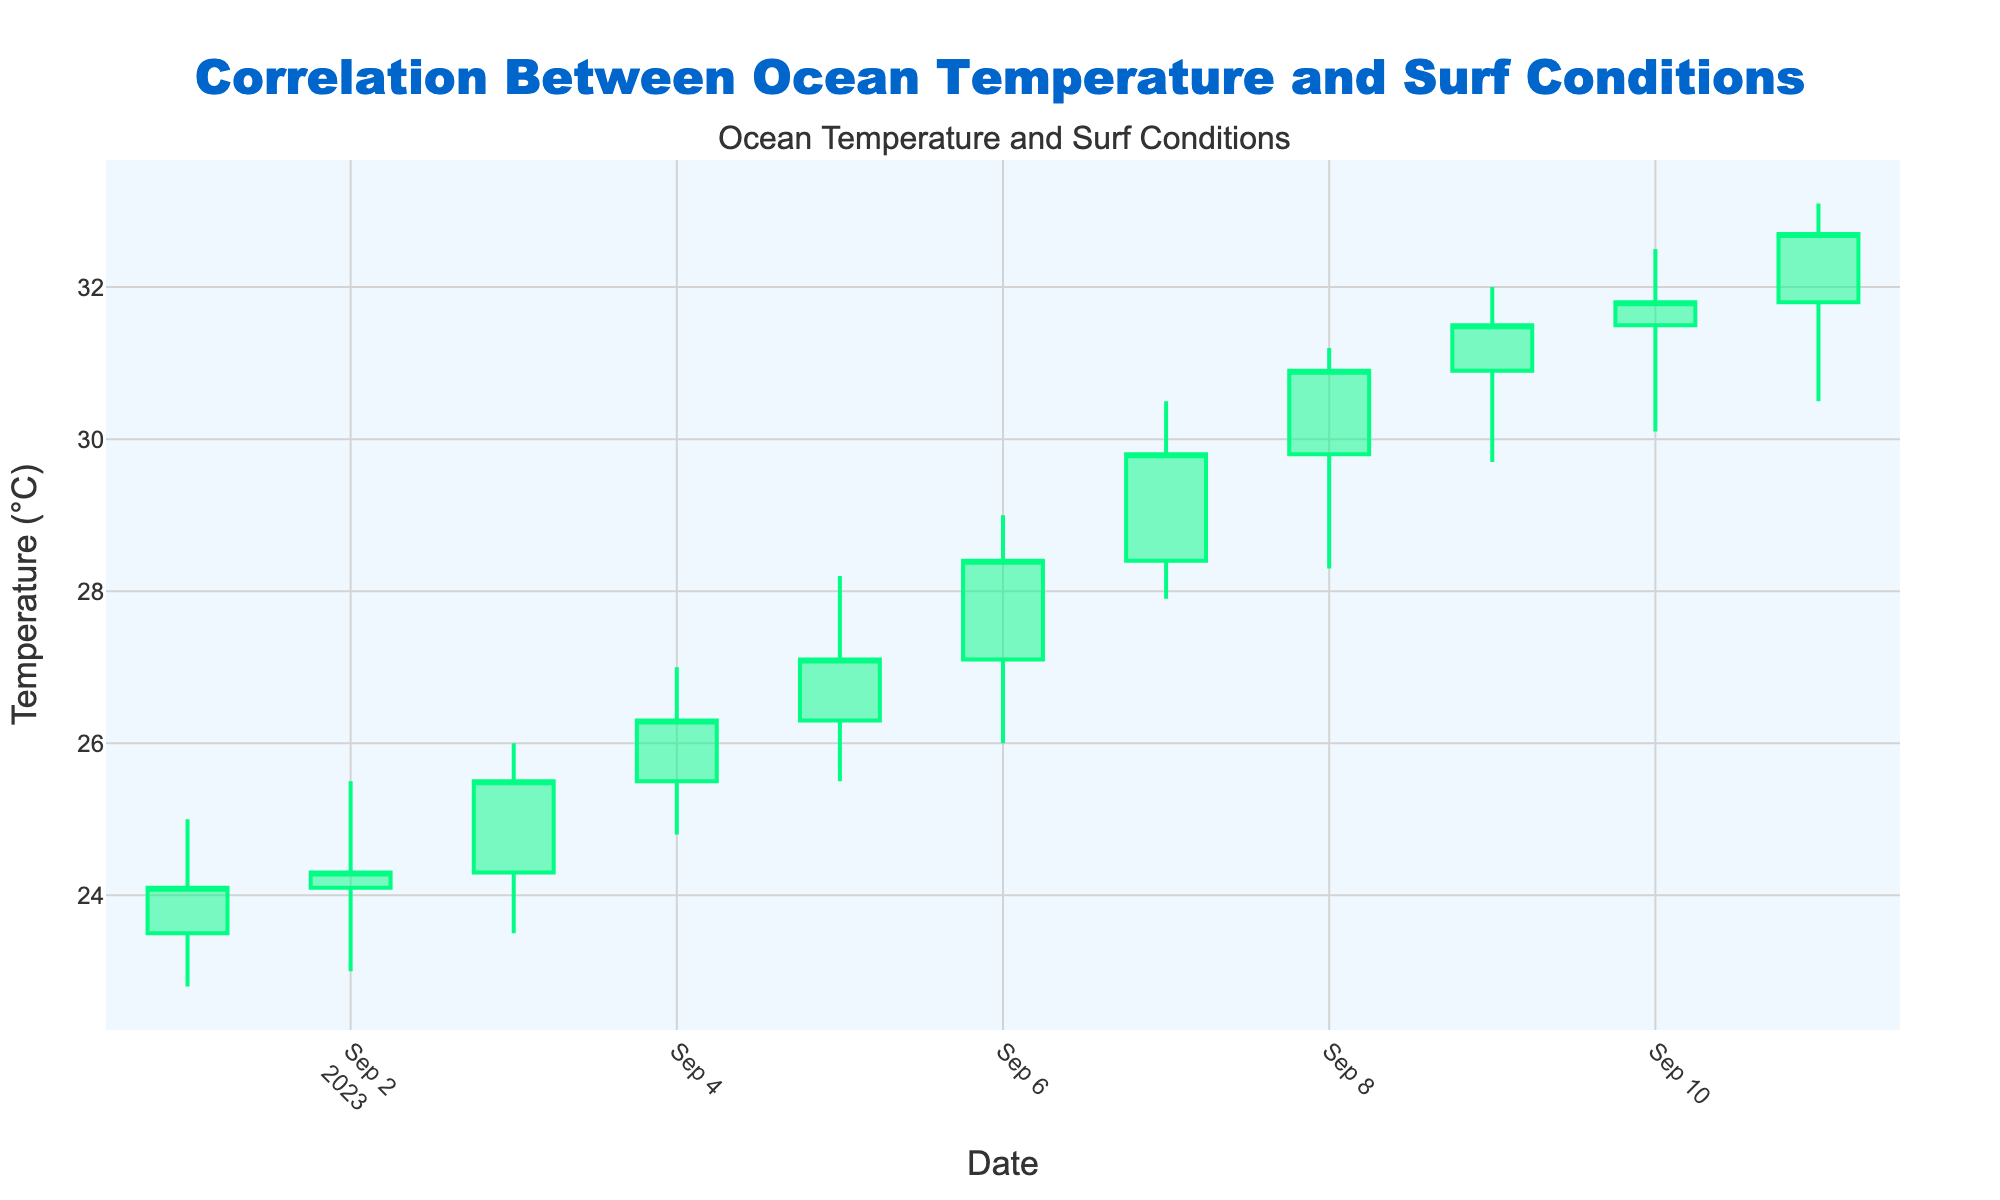What is the title of the figure? The title of the figure can be found at the top center section of the chart. It reads "Correlation Between Ocean Temperature and Surf Conditions".
Answer: Correlation Between Ocean Temperature and Surf Conditions Which date shows the highest ocean temperature based on the candlestick chart? By examining the "High" values on the candlestick chart, the date with the highest ocean temperature is when the High value reaches its peak. The highest temperature is on 2023-09-11, where the High value is 33.1°C.
Answer: 2023-09-11 On which dates did the Close temperature exceed 30°C? Review all the "Close" values displayed on the candlestick chart and identify which ones are above 30°C. The dates where the Close temperature exceeded 30°C are 2023-09-08, 2023-09-09, 2023-09-10, and 2023-09-11.
Answer: 2023-09-08, 2023-09-09, 2023-09-10, 2023-09-11 How does the opening temperature change from the first day to the last day in the provided dataset? Compare the "Open" temperature on the first day (2023-09-01) which is 23.5°C, to the "Open" temperature on the last day (2023-09-11) which is 31.8°C. The opening temperature increased from 23.5°C to 31.8°C.
Answer: Increased from 23.5°C to 31.8°C What is the range of temperatures on 2023-09-05? The range is calculated by subtracting the Low value from the High value for 2023-09-05. The High is 28.2°C and Low is 25.5°C, so the range is 28.2°C - 25.5°C = 2.7°C.
Answer: 2.7°C Which day showed the largest single-day increase in closing temperature? To determine the largest single-day increase, calculate the difference between the previous day's Close and the current day's Close for each day. Comparing all the differences, the largest increase is between 2023-09-06 and 2023-09-07, where the Close increased from 28.4°C to 29.8°C, an increase of 1.4°C.
Answer: 2023-09-07 On what date did the closing temperature decrease compared to the previous day? Compare the closing temperature of consecutive days and identify where the Close value is lower than the previous day. This occurs between 2023-09-10 and 2023-09-11, where the Close fell from 31.8°C to 32.7°C.
Answer: 2023-09-10 What is the average closing temperature over the entire period? Sum all the closing values and then divide by the number of days. The closing temperatures are: 24.1, 24.3, 25.5, 26.3, 27.1, 28.4, 29.8, 30.9, 31.5, 31.8, 32.7. The sum is 312.4, and there are 11 values, so the average is 312.4 / 11 = 28.4°C.
Answer: 28.4°C 